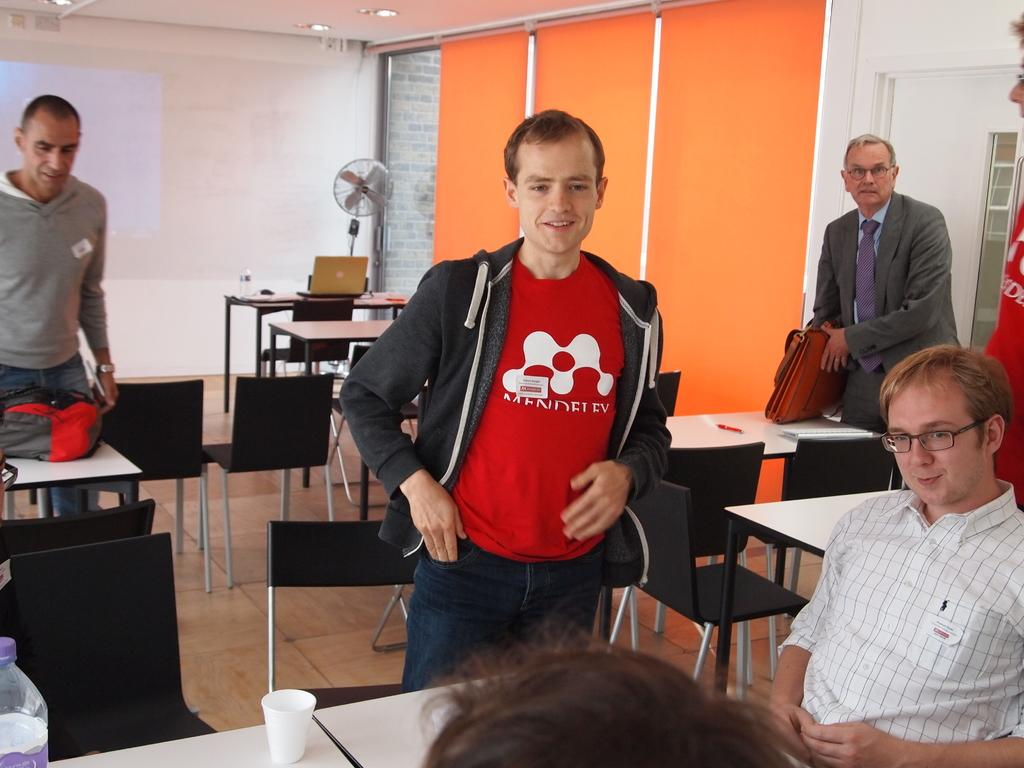What are the people in the image doing? There is a group of people standing in the image. Can you describe the position of the person on the right side of the image? There is a person sitting on the right side of the image. What furniture can be seen in the image? There are chairs in the image. What is visible in the background of the image? There is a wall visible in the background of the image. What type of linen can be seen hanging on the wall in the image? There is no linen visible in the image; only a wall is present in the background. 